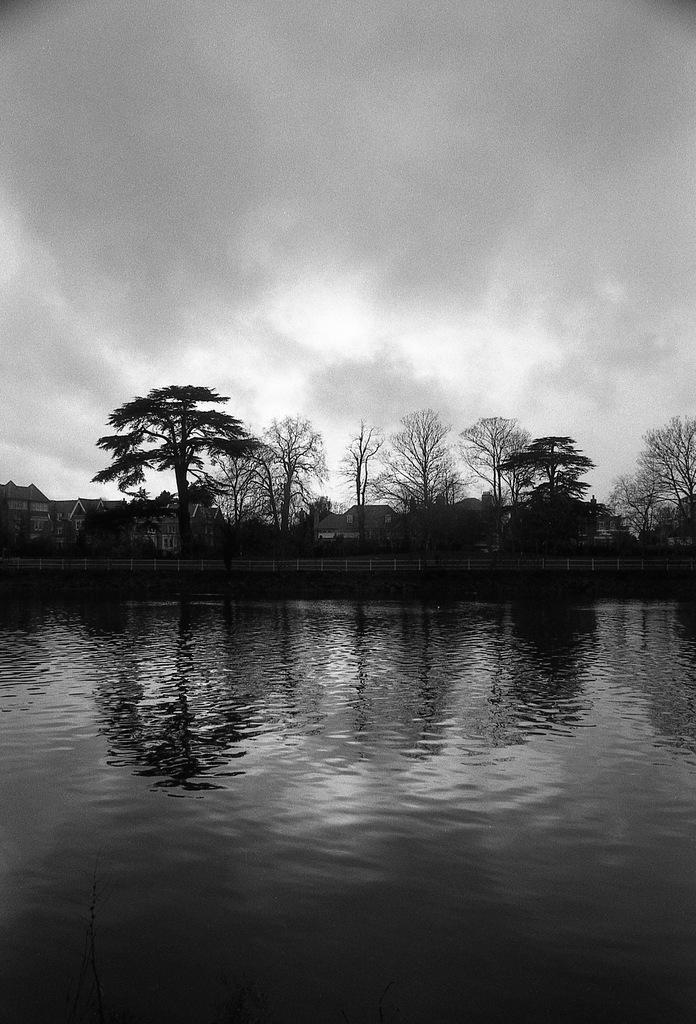Please provide a concise description of this image. In this image I can see the lake , there are some trees in the middle , at the top I can see the sky. 